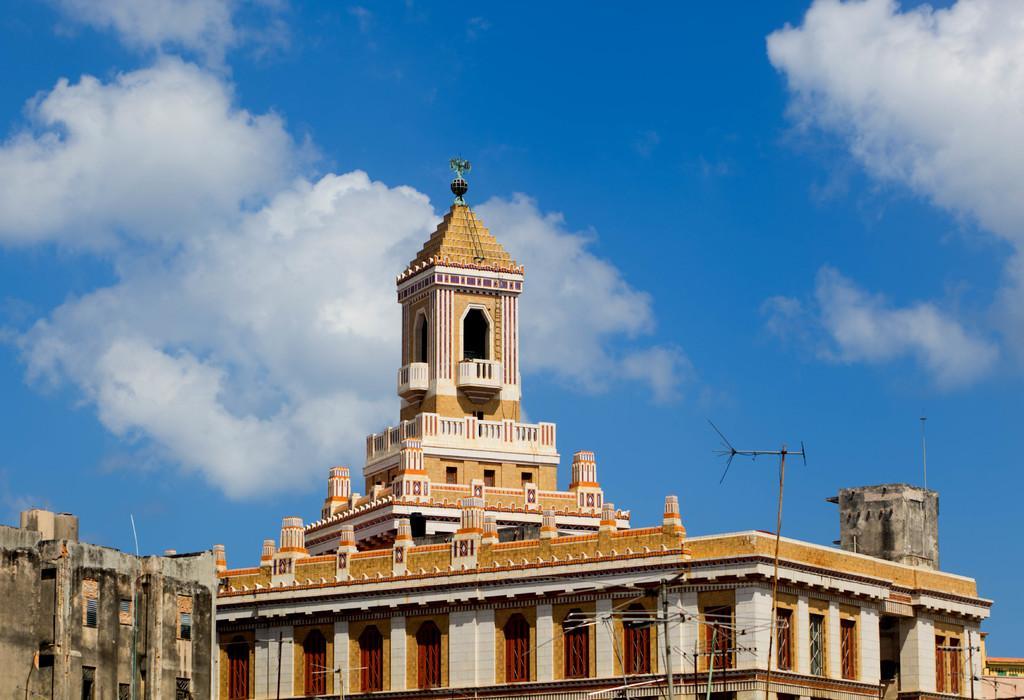Describe this image in one or two sentences. In this image there are buildings, in front of the buildings there are antennas, at the top of the image there are clouds in the sky. 